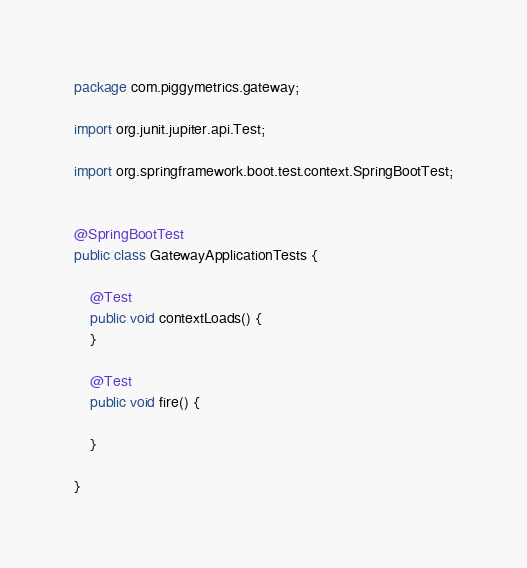<code> <loc_0><loc_0><loc_500><loc_500><_Java_>package com.piggymetrics.gateway;

import org.junit.jupiter.api.Test;

import org.springframework.boot.test.context.SpringBootTest;


@SpringBootTest
public class GatewayApplicationTests {

	@Test
	public void contextLoads() {
	}

	@Test
	public void fire() {

	}

}
</code> 